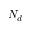<formula> <loc_0><loc_0><loc_500><loc_500>N _ { d }</formula> 